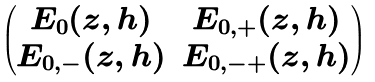<formula> <loc_0><loc_0><loc_500><loc_500>\begin{pmatrix} E _ { 0 } ( z , h ) & E _ { 0 , + } ( z , h ) \\ E _ { 0 , - } ( z , h ) & E _ { 0 , - + } ( z , h ) \end{pmatrix}</formula> 